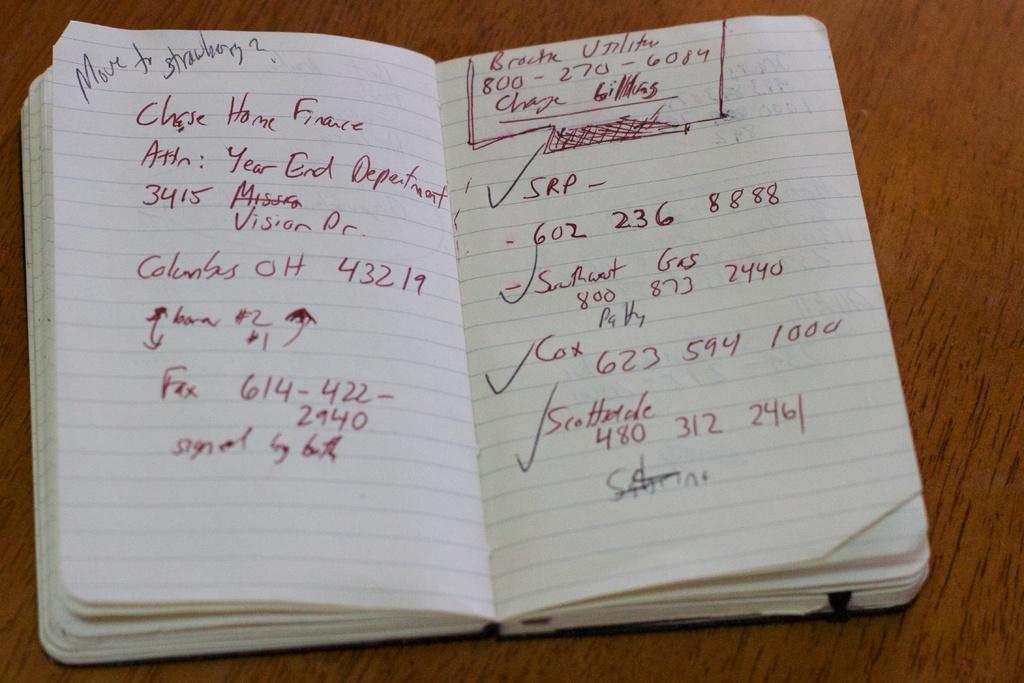Describe this image in one or two sentences. In this image I can see a book and something is written on it. Book is on the brown color surface. 